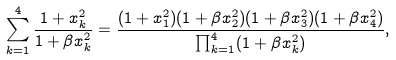<formula> <loc_0><loc_0><loc_500><loc_500>\sum _ { k = 1 } ^ { 4 } \frac { 1 + x _ { k } ^ { 2 } } { 1 + \beta x _ { k } ^ { 2 } } = \frac { ( 1 + x _ { 1 } ^ { 2 } ) ( 1 + \beta x _ { 2 } ^ { 2 } ) ( 1 + \beta x _ { 3 } ^ { 2 } ) ( 1 + \beta x _ { 4 } ^ { 2 } ) } { \prod _ { k = 1 } ^ { 4 } ( 1 + \beta x _ { k } ^ { 2 } ) } ,</formula> 